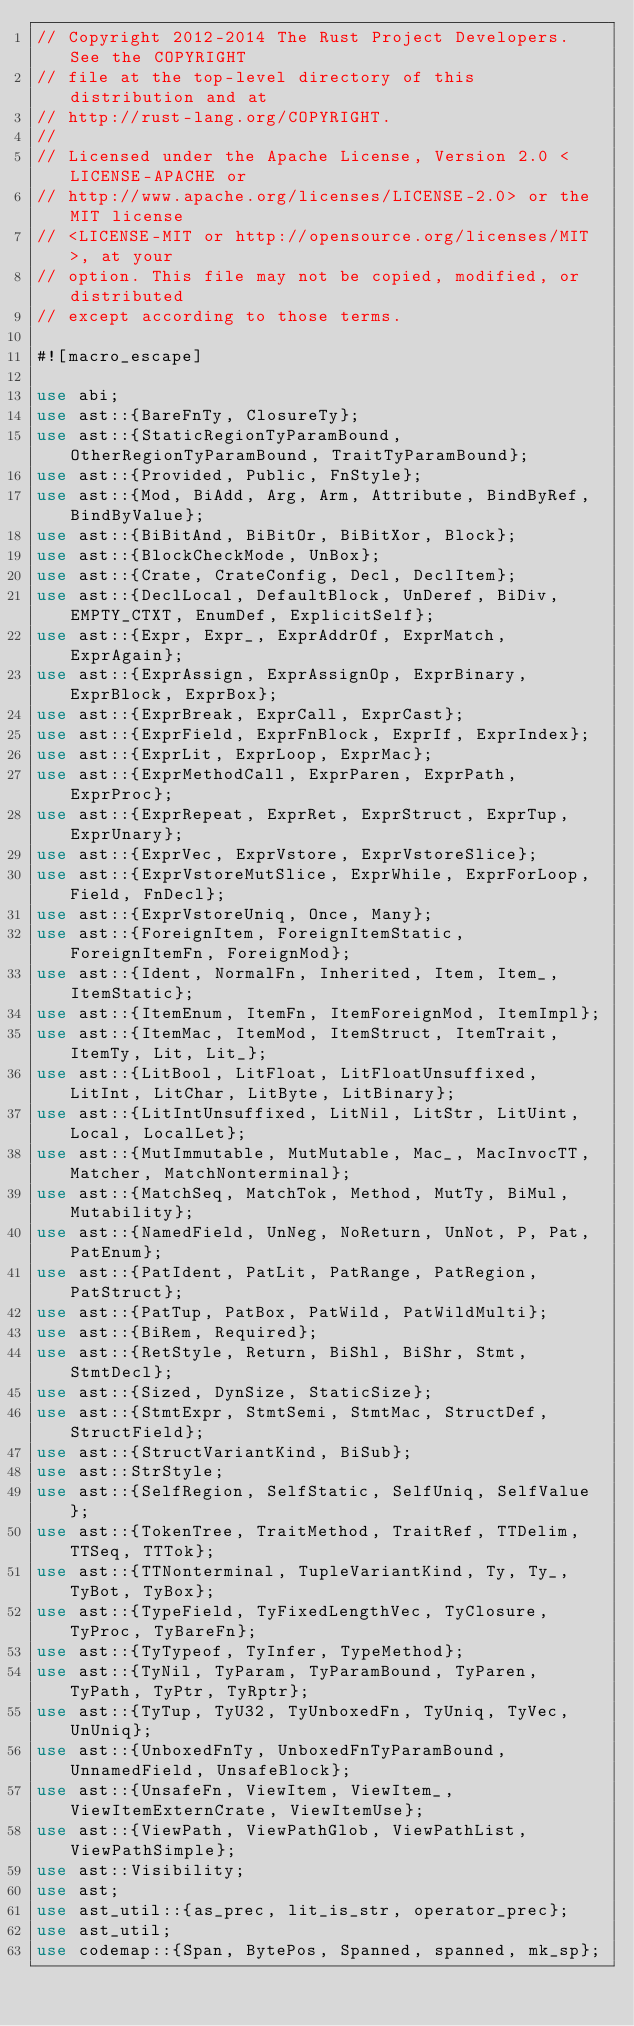Convert code to text. <code><loc_0><loc_0><loc_500><loc_500><_Rust_>// Copyright 2012-2014 The Rust Project Developers. See the COPYRIGHT
// file at the top-level directory of this distribution and at
// http://rust-lang.org/COPYRIGHT.
//
// Licensed under the Apache License, Version 2.0 <LICENSE-APACHE or
// http://www.apache.org/licenses/LICENSE-2.0> or the MIT license
// <LICENSE-MIT or http://opensource.org/licenses/MIT>, at your
// option. This file may not be copied, modified, or distributed
// except according to those terms.

#![macro_escape]

use abi;
use ast::{BareFnTy, ClosureTy};
use ast::{StaticRegionTyParamBound, OtherRegionTyParamBound, TraitTyParamBound};
use ast::{Provided, Public, FnStyle};
use ast::{Mod, BiAdd, Arg, Arm, Attribute, BindByRef, BindByValue};
use ast::{BiBitAnd, BiBitOr, BiBitXor, Block};
use ast::{BlockCheckMode, UnBox};
use ast::{Crate, CrateConfig, Decl, DeclItem};
use ast::{DeclLocal, DefaultBlock, UnDeref, BiDiv, EMPTY_CTXT, EnumDef, ExplicitSelf};
use ast::{Expr, Expr_, ExprAddrOf, ExprMatch, ExprAgain};
use ast::{ExprAssign, ExprAssignOp, ExprBinary, ExprBlock, ExprBox};
use ast::{ExprBreak, ExprCall, ExprCast};
use ast::{ExprField, ExprFnBlock, ExprIf, ExprIndex};
use ast::{ExprLit, ExprLoop, ExprMac};
use ast::{ExprMethodCall, ExprParen, ExprPath, ExprProc};
use ast::{ExprRepeat, ExprRet, ExprStruct, ExprTup, ExprUnary};
use ast::{ExprVec, ExprVstore, ExprVstoreSlice};
use ast::{ExprVstoreMutSlice, ExprWhile, ExprForLoop, Field, FnDecl};
use ast::{ExprVstoreUniq, Once, Many};
use ast::{ForeignItem, ForeignItemStatic, ForeignItemFn, ForeignMod};
use ast::{Ident, NormalFn, Inherited, Item, Item_, ItemStatic};
use ast::{ItemEnum, ItemFn, ItemForeignMod, ItemImpl};
use ast::{ItemMac, ItemMod, ItemStruct, ItemTrait, ItemTy, Lit, Lit_};
use ast::{LitBool, LitFloat, LitFloatUnsuffixed, LitInt, LitChar, LitByte, LitBinary};
use ast::{LitIntUnsuffixed, LitNil, LitStr, LitUint, Local, LocalLet};
use ast::{MutImmutable, MutMutable, Mac_, MacInvocTT, Matcher, MatchNonterminal};
use ast::{MatchSeq, MatchTok, Method, MutTy, BiMul, Mutability};
use ast::{NamedField, UnNeg, NoReturn, UnNot, P, Pat, PatEnum};
use ast::{PatIdent, PatLit, PatRange, PatRegion, PatStruct};
use ast::{PatTup, PatBox, PatWild, PatWildMulti};
use ast::{BiRem, Required};
use ast::{RetStyle, Return, BiShl, BiShr, Stmt, StmtDecl};
use ast::{Sized, DynSize, StaticSize};
use ast::{StmtExpr, StmtSemi, StmtMac, StructDef, StructField};
use ast::{StructVariantKind, BiSub};
use ast::StrStyle;
use ast::{SelfRegion, SelfStatic, SelfUniq, SelfValue};
use ast::{TokenTree, TraitMethod, TraitRef, TTDelim, TTSeq, TTTok};
use ast::{TTNonterminal, TupleVariantKind, Ty, Ty_, TyBot, TyBox};
use ast::{TypeField, TyFixedLengthVec, TyClosure, TyProc, TyBareFn};
use ast::{TyTypeof, TyInfer, TypeMethod};
use ast::{TyNil, TyParam, TyParamBound, TyParen, TyPath, TyPtr, TyRptr};
use ast::{TyTup, TyU32, TyUnboxedFn, TyUniq, TyVec, UnUniq};
use ast::{UnboxedFnTy, UnboxedFnTyParamBound, UnnamedField, UnsafeBlock};
use ast::{UnsafeFn, ViewItem, ViewItem_, ViewItemExternCrate, ViewItemUse};
use ast::{ViewPath, ViewPathGlob, ViewPathList, ViewPathSimple};
use ast::Visibility;
use ast;
use ast_util::{as_prec, lit_is_str, operator_prec};
use ast_util;
use codemap::{Span, BytePos, Spanned, spanned, mk_sp};</code> 